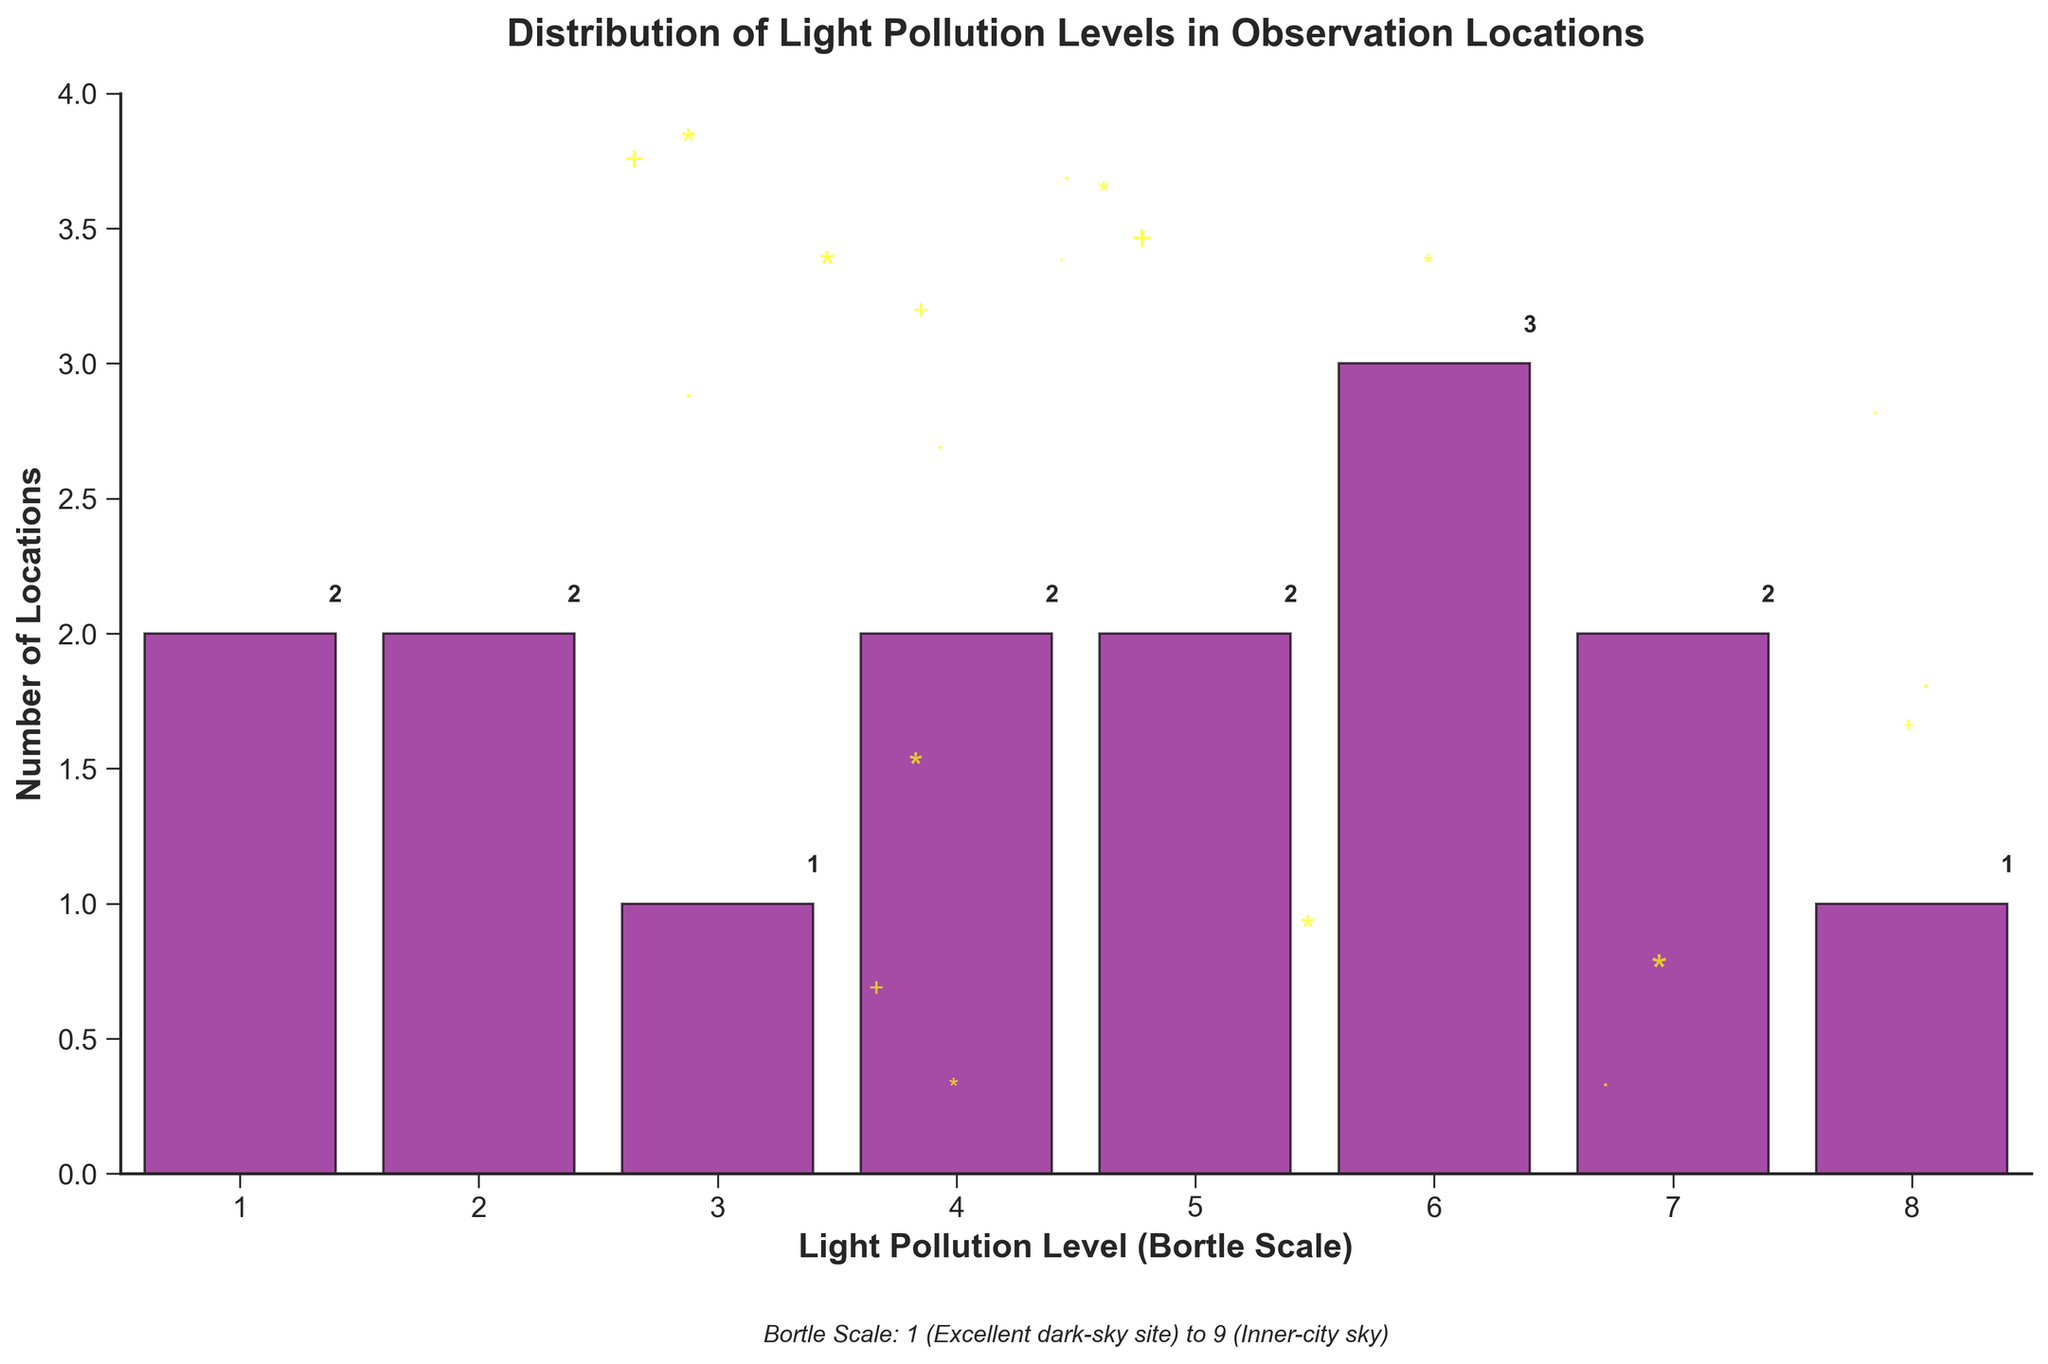What is the title of the figure? The first thing to look for in a plot is usually the title at the top to understand the data context. In this figure, the title is placed prominently.
Answer: Distribution of Light Pollution Levels in Observation Locations How many locations have a light pollution level of 2? Find the bin labeled "2" on the x-axis and look at the height of the corresponding bar. The number above the bar provides the value.
Answer: 2 Which light pollution level has the highest number of locations? Identify the tallest bar in the histogram and note the corresponding value on the x-axis.
Answer: 6 What is the total number of locations represented in the histogram? Summing the values on top of each bar gives the total count since each bar represents a number of locations.
Answer: 15 How many locations have light pollution levels of 7 or higher? Observe the bars corresponding to "7" and "8" on the x-axis and add the respective values together.
Answer: 3 Is the number of locations with light pollution levels less than 3 higher or lower than those with levels greater than 7? Count the values for levels 1 and 2, then compare with the values for level 8.
Answer: Higher What is the average light pollution level across all locations? Sum the result of each light pollution level multiplied by the count of locations and then divide by the total number of locations.
Answer: 4.47 Which light pollution levels have the least number of locations? Find the shortest bars in the histogram and note the corresponding x-axis values.
Answer: 8 How does the number of locations with a light pollution level of 4 compare to those with a level of 5? Observe the bars for levels "4" and "5" and compare their heights/numbers.
Answer: Equal What can we infer about urban versus rural observation locations based on the histogram? Higher Bortle scale levels indicate more light pollution, typically found in urban areas, whereas lower levels indicate rural or natural areas with less light pollution. Thus, we can infer more locations with higher light pollution are urban, and those with lower levels are rural.
Answer: Urban areas tend to have higher light pollution levels 